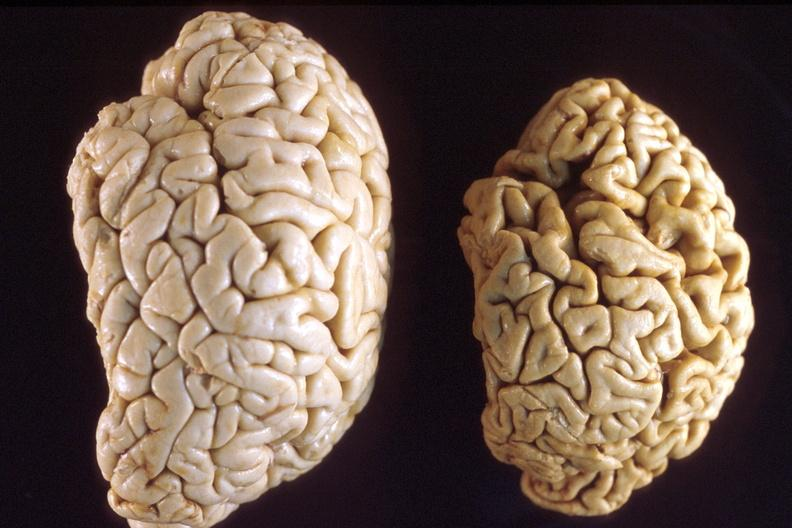does nipple duplication show brain, atrophy and normal?
Answer the question using a single word or phrase. No 